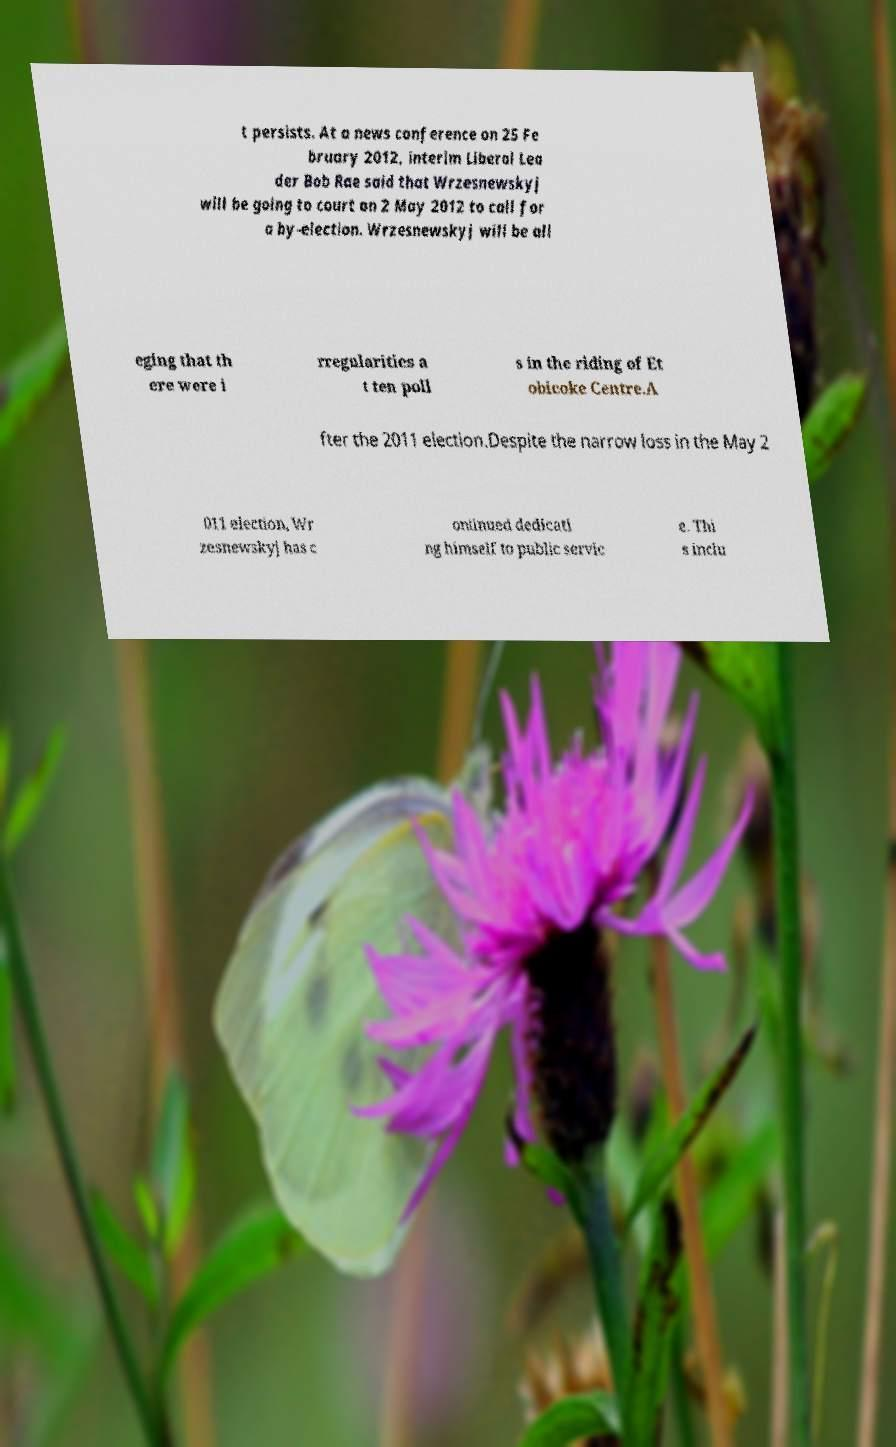Could you extract and type out the text from this image? t persists. At a news conference on 25 Fe bruary 2012, interim Liberal Lea der Bob Rae said that Wrzesnewskyj will be going to court on 2 May 2012 to call for a by-election. Wrzesnewskyj will be all eging that th ere were i rregularities a t ten poll s in the riding of Et obicoke Centre.A fter the 2011 election.Despite the narrow loss in the May 2 011 election, Wr zesnewskyj has c ontinued dedicati ng himself to public servic e. Thi s inclu 